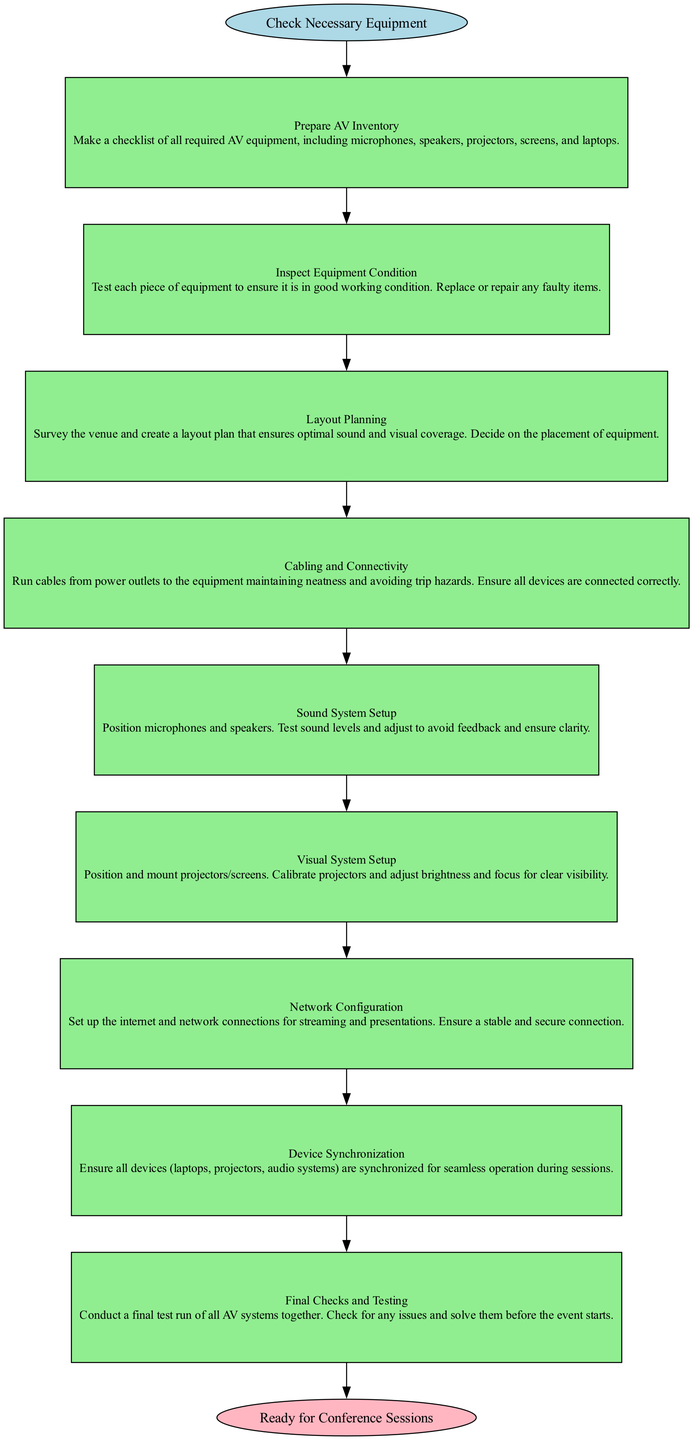What is the starting point of the flow chart? The diagram begins with the node labeled "Check Necessary Equipment." This indicates the first action to take when setting up AV equipment.
Answer: Check Necessary Equipment How many steps are there in the diagram? The diagram contains nine steps, each of which represents a specific action needed to set up the AV equipment for the conference sessions. They are sequentially numbered from one to nine.
Answer: Nine What is the final step before being ready for conference sessions? The last step in the sequence is "Final Checks and Testing," which indicates the last testing phase before the equipment is declared ready for use.
Answer: Final Checks and Testing Which step involves securing a stable internet connection? The step labeled "Network Configuration" specifically addresses the setup of internet and network connections, ensuring stability for streaming and presentations.
Answer: Network Configuration Describe the relationship between "Inspect Equipment Condition" and "Layout Planning." "Inspect Equipment Condition" is the second step that leads into "Layout Planning," the third step. This indicates that after ensuring the equipment is functioning, layout planning follows next in the process.
Answer: Sequential relationship What is the main purpose of the "Cabling and Connectivity" step? The primary purpose of the "Cabling and Connectivity" step is to ensure all devices are properly connected while maintaining neatness and avoiding trip hazards.
Answer: Proper device connections Which step requires adjusting sound levels to avoid feedback? The step titled "Sound System Setup" focuses on positioning microphones and speakers and adjusting sound levels to ensure clarity without feedback issues.
Answer: Sound System Setup What type of equipment is set up in the "Visual System Setup" step? This step specifically mentions setting up projectors and screens, including their calibration for optimal visibility during sessions.
Answer: Projectors and screens What comes after "Device Synchronization" in the flow? Following "Device Synchronization," the next step in the diagram is "Final Checks and Testing," which suggests a final review and testing phase after syncing devices.
Answer: Final Checks and Testing 